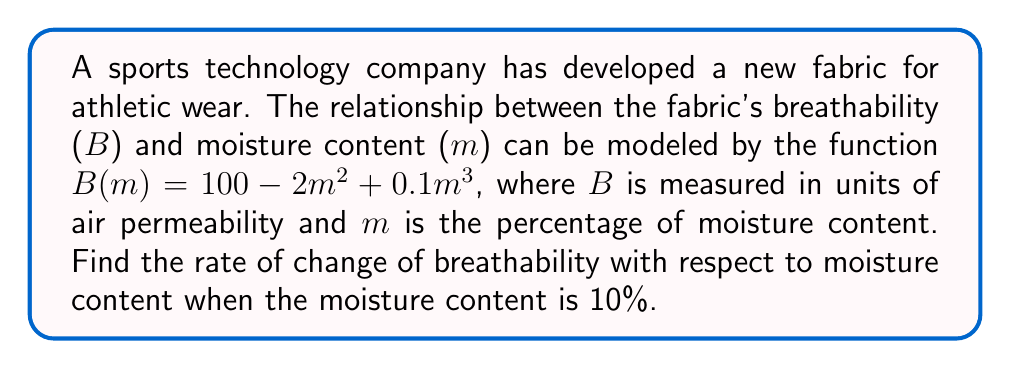Can you answer this question? To find the rate of change of breathability with respect to moisture content, we need to calculate the derivative of the function $B(m)$ and then evaluate it at $m = 10$.

Step 1: Calculate the derivative of $B(m)$.
$$\begin{align}
B(m) &= 100 - 2m^2 + 0.1m^3 \\
B'(m) &= 0 - 4m + 0.3m^2
\end{align}$$

Step 2: Simplify the derivative.
$$B'(m) = -4m + 0.3m^2$$

Step 3: Evaluate the derivative at $m = 10$.
$$\begin{align}
B'(10) &= -4(10) + 0.3(10)^2 \\
&= -40 + 0.3(100) \\
&= -40 + 30 \\
&= -10
\end{align}$$

Therefore, when the moisture content is 10%, the rate of change of breathability with respect to moisture content is -10 units of air permeability per percentage of moisture content.
Answer: $-10$ units of air permeability per percentage of moisture content 